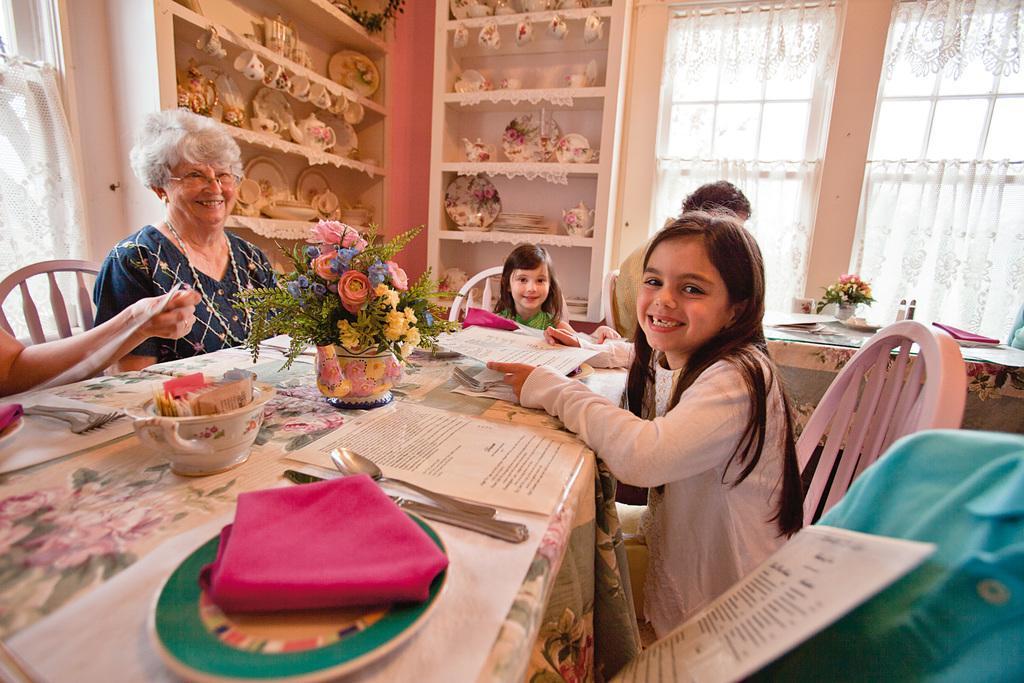How would you summarize this image in a sentence or two? In this image I can see a woman,two girls and a man sitting on a chair. This is a rack where cups,kettle,plates and some ceramic items are kept. This is a table. There is a flower vase,bowl,plate ,napkin ,spoon,knife and some papers placed on it. At the left corner of the image I can another person's hand. And this is a window with white curtains. 